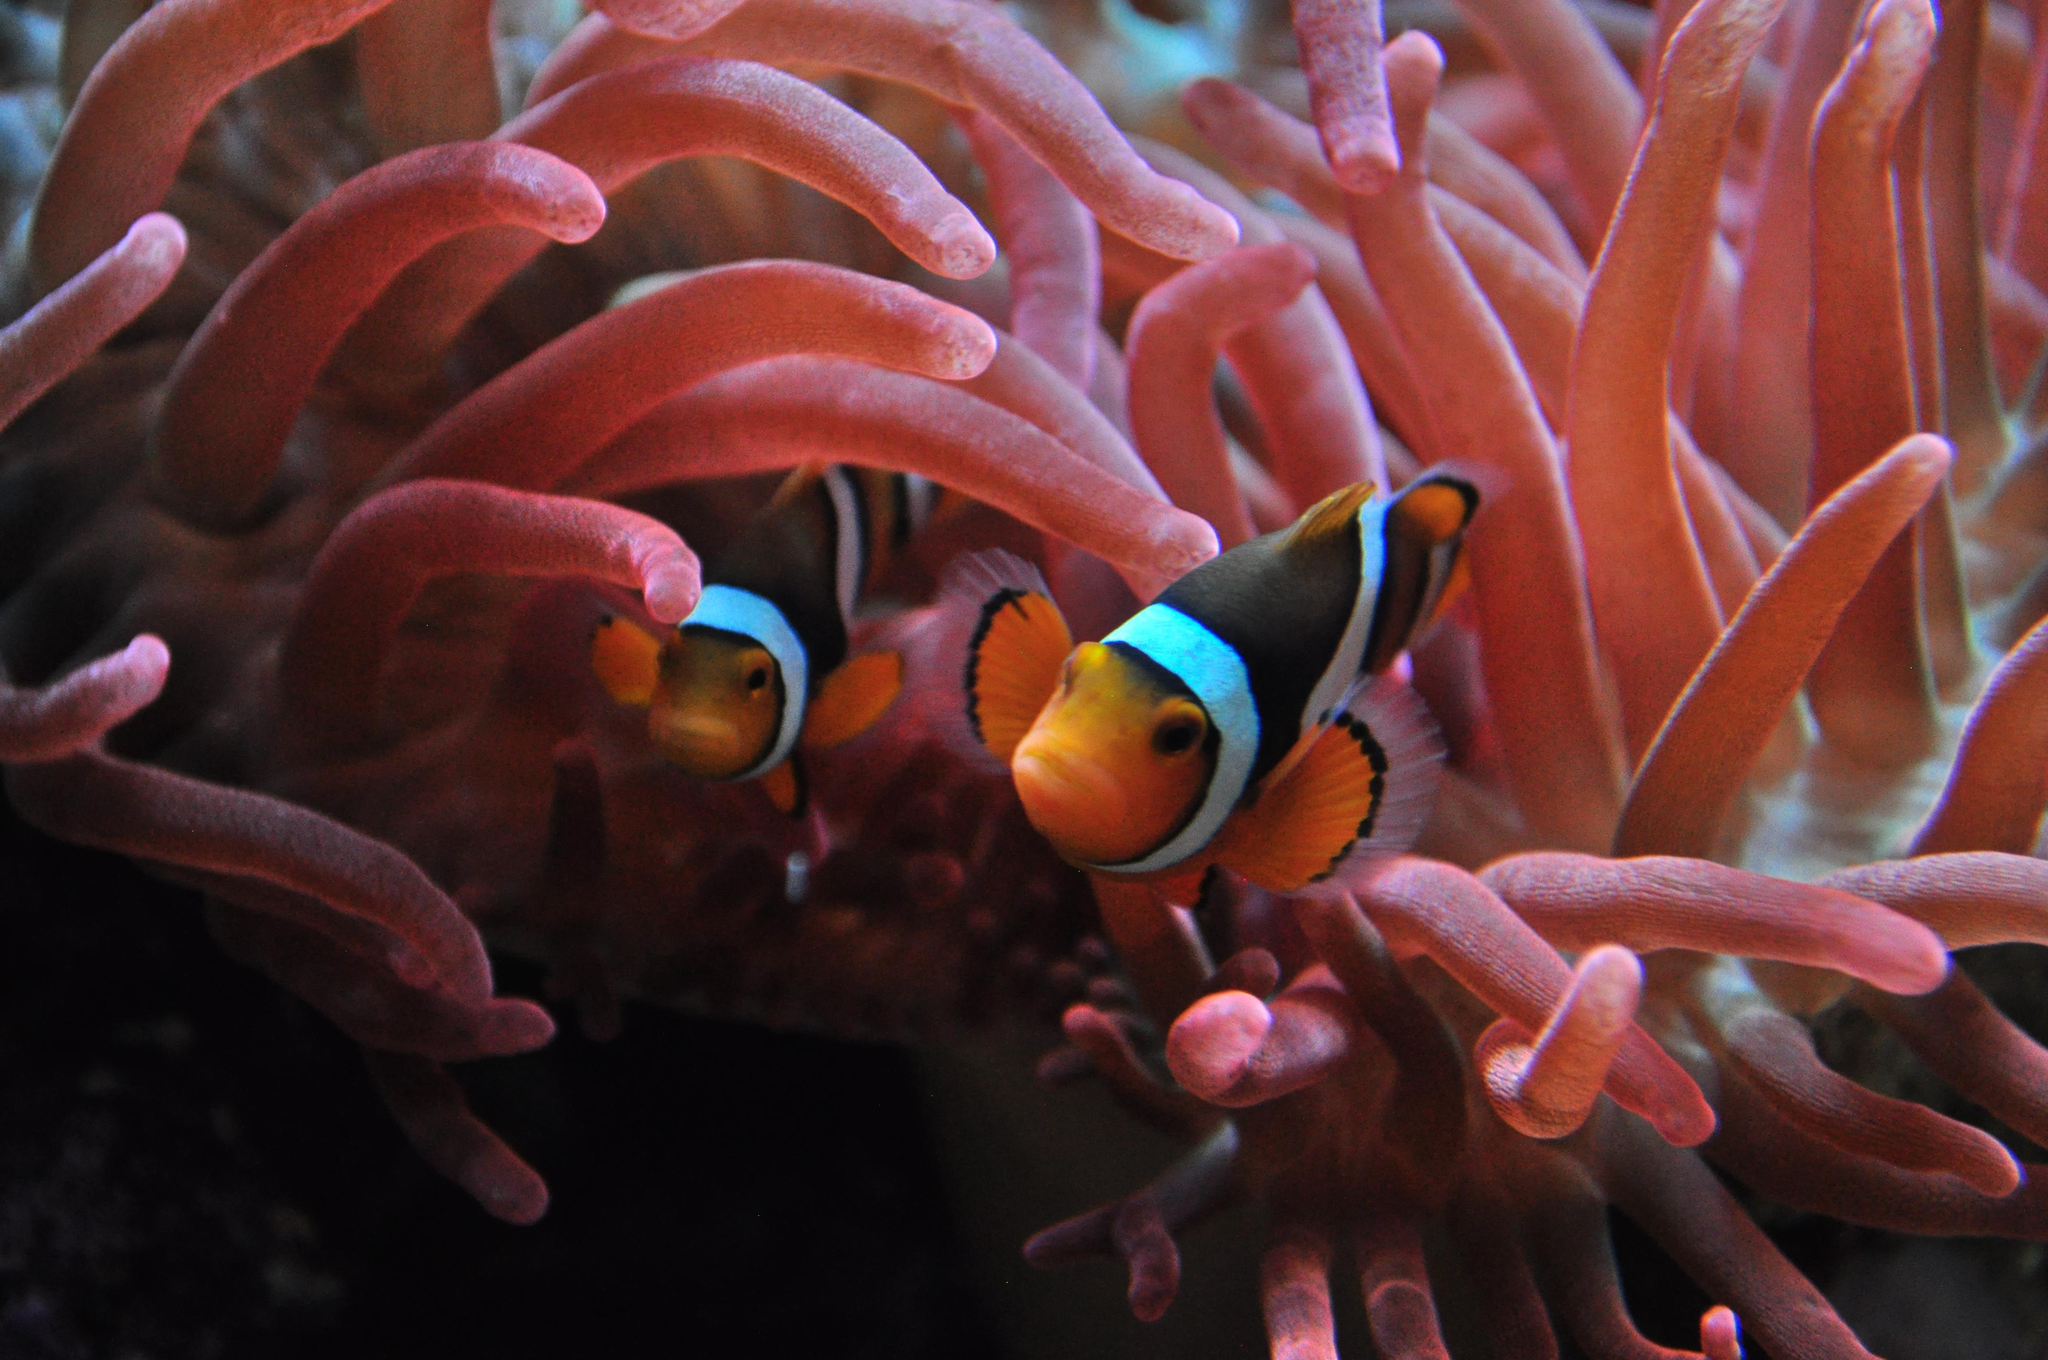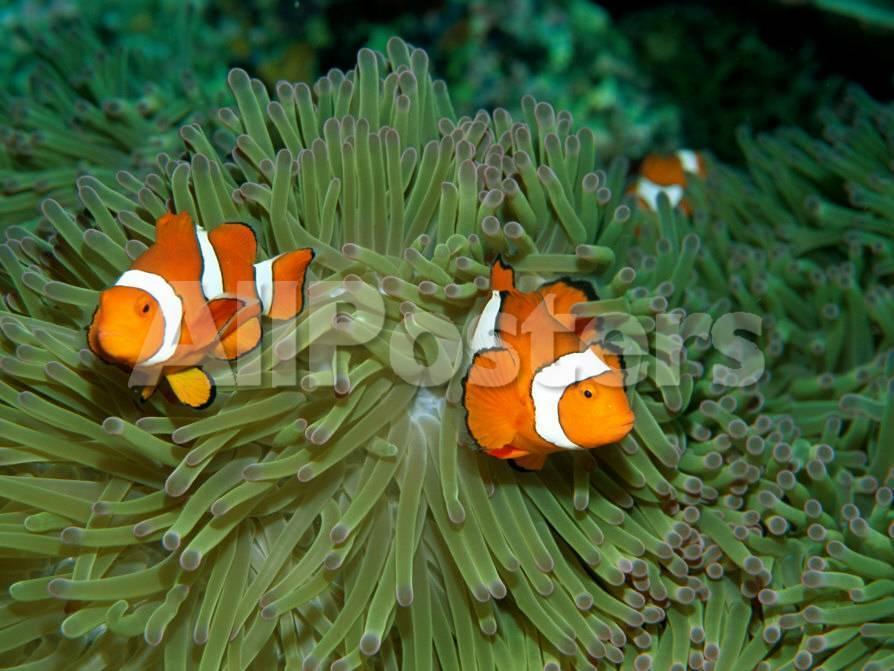The first image is the image on the left, the second image is the image on the right. For the images shown, is this caption "One image shows orange-and-white clownfish swimming among yellowish tendrils, and the other shows white-striped fish with a bright yellow body." true? Answer yes or no. No. The first image is the image on the left, the second image is the image on the right. Analyze the images presented: Is the assertion "At least one fish is yellow." valid? Answer yes or no. No. 